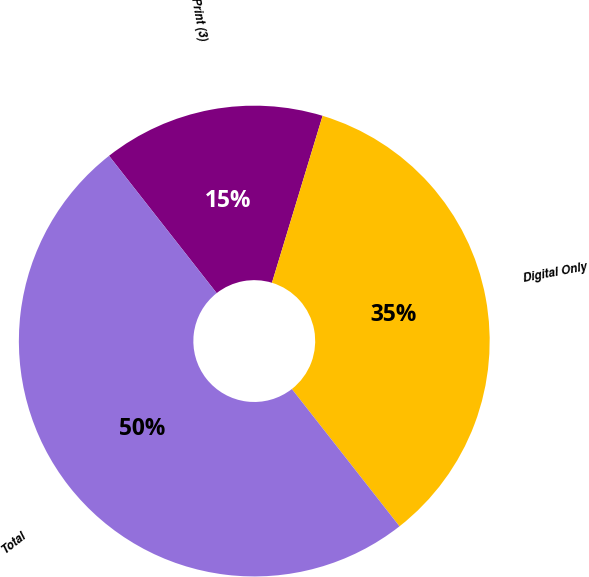<chart> <loc_0><loc_0><loc_500><loc_500><pie_chart><fcel>Print (3)<fcel>Digital Only<fcel>Total<nl><fcel>15.27%<fcel>34.73%<fcel>50.0%<nl></chart> 